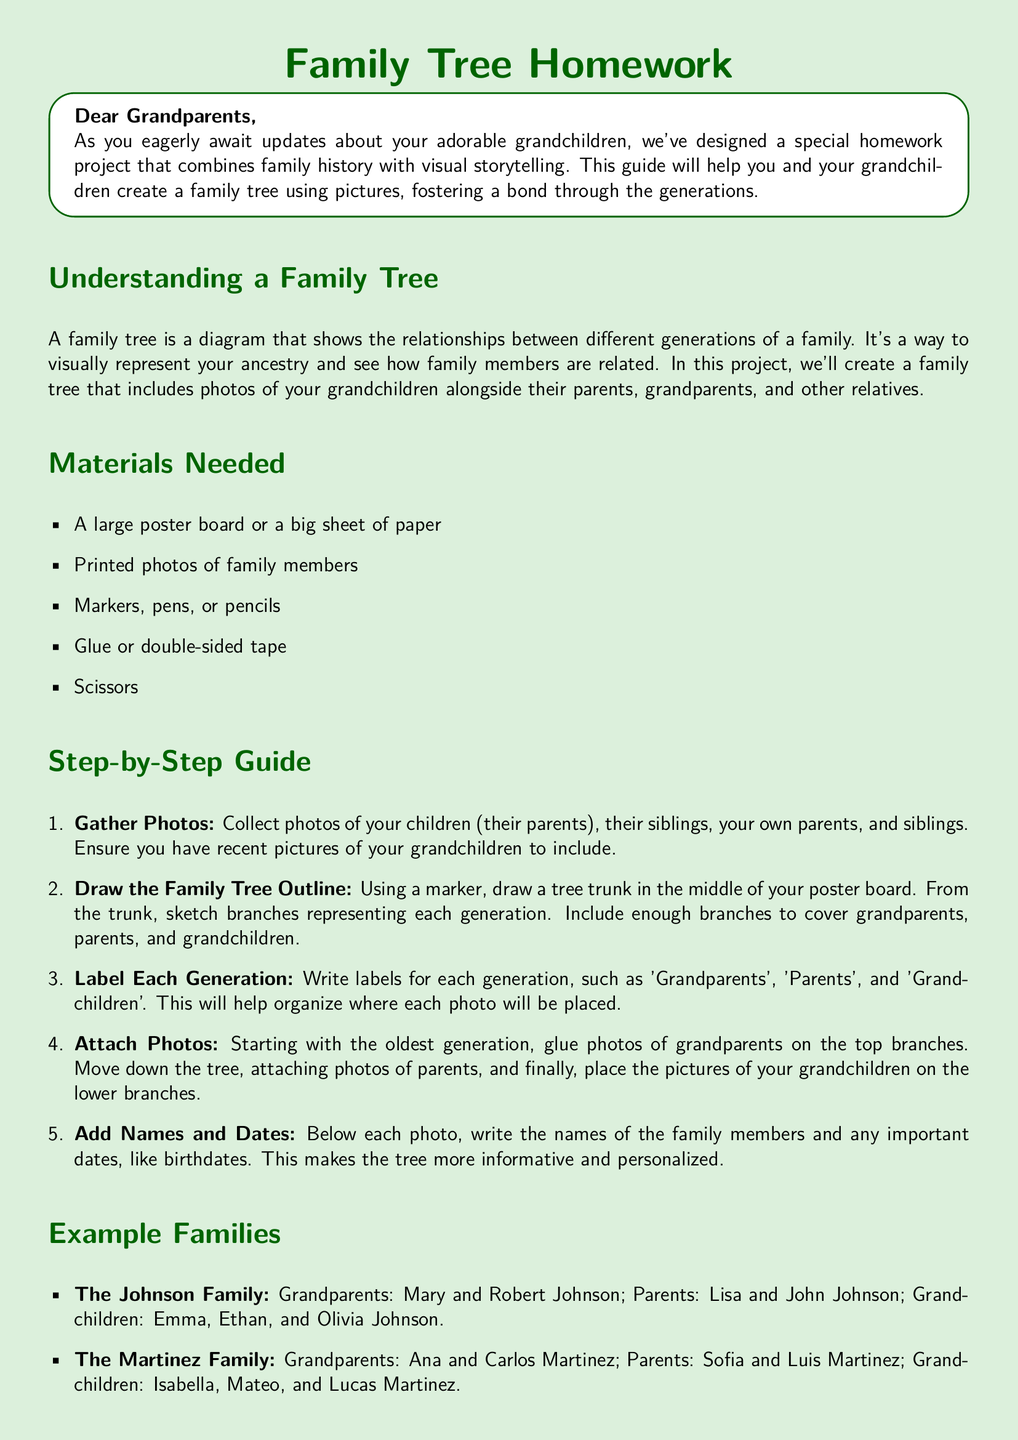What is the title of the homework? The title of the homework is prominently displayed at the beginning of the document, serving as the main heading.
Answer: Family Tree Homework What materials are needed for the project? The document lists specific items necessary to complete the family tree project under the "Materials Needed" section.
Answer: Poster board, photos, markers, glue, scissors Who are the grandparents in the Johnson family example? The Johnson family example provides names of the grandparents under the "Example Families" section.
Answer: Mary and Robert Johnson What is the first step in the step-by-step guide? The first step of the guide outlines the initial task that must be performed to start the project.
Answer: Gather Photos How many grandchildren are mentioned in the Johnson family? The number of grandchildren mentioned in the Johnson family is derived from the example provided in the document.
Answer: Three Why is creating a family tree important? The document discusses the significance of the family tree project, explaining its benefits in a specific section.
Answer: Understand heritage What is indicated below each photo on the family tree? The document describes what should be added below each family member's photo in the project.
Answer: Names and dates How many generations should the tree cover? The document specifies that the family tree should include multiple generations as part of the project guidelines.
Answer: Three 